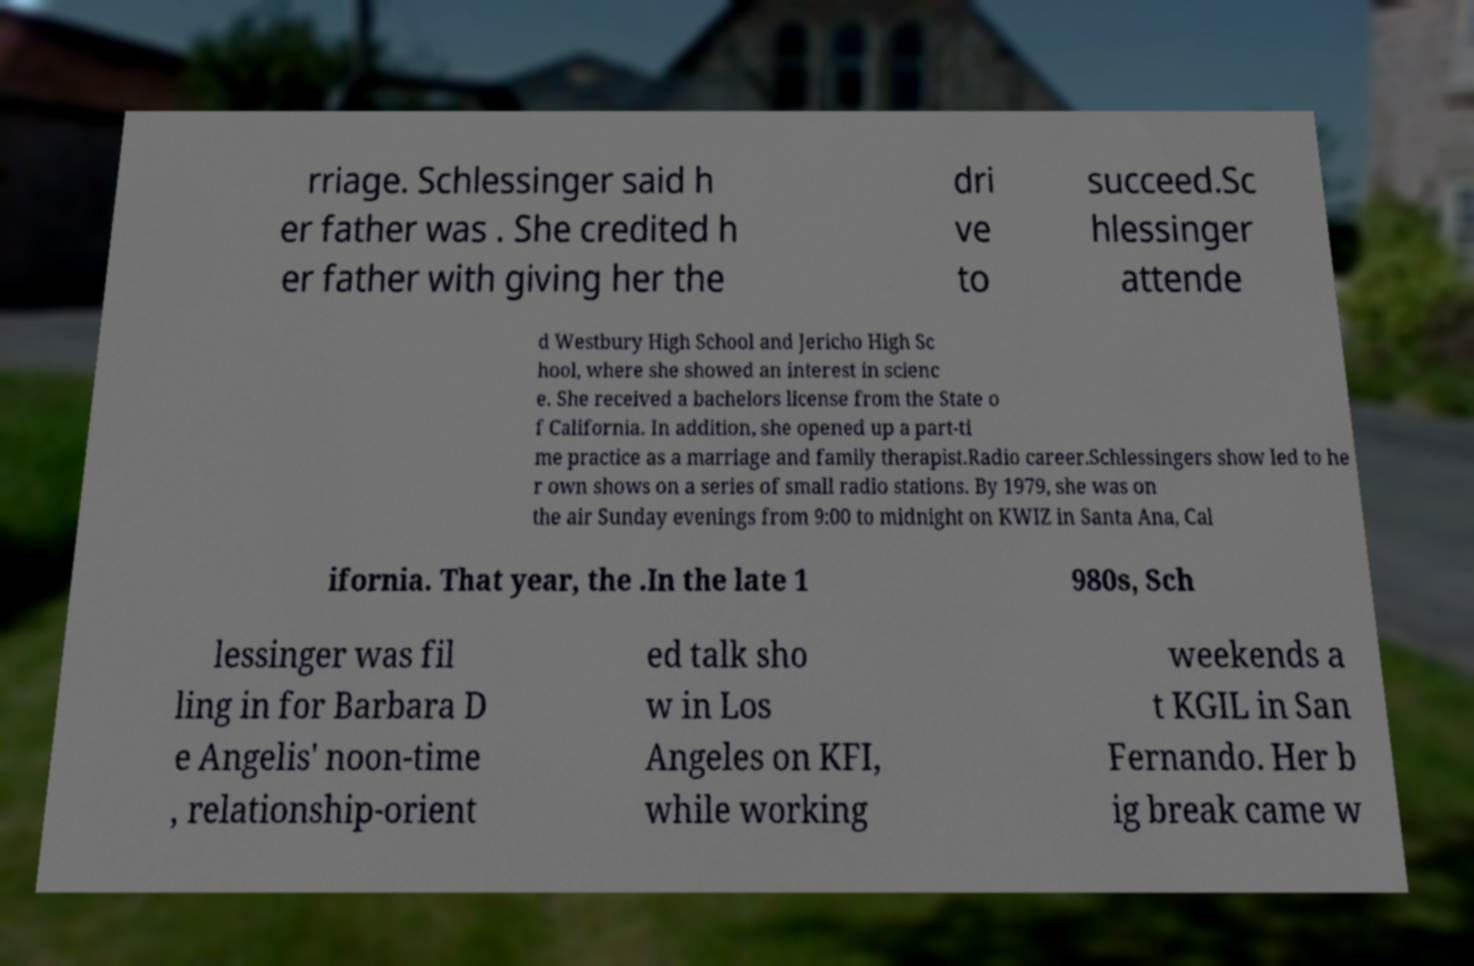There's text embedded in this image that I need extracted. Can you transcribe it verbatim? rriage. Schlessinger said h er father was . She credited h er father with giving her the dri ve to succeed.Sc hlessinger attende d Westbury High School and Jericho High Sc hool, where she showed an interest in scienc e. She received a bachelors license from the State o f California. In addition, she opened up a part-ti me practice as a marriage and family therapist.Radio career.Schlessingers show led to he r own shows on a series of small radio stations. By 1979, she was on the air Sunday evenings from 9:00 to midnight on KWIZ in Santa Ana, Cal ifornia. That year, the .In the late 1 980s, Sch lessinger was fil ling in for Barbara D e Angelis' noon-time , relationship-orient ed talk sho w in Los Angeles on KFI, while working weekends a t KGIL in San Fernando. Her b ig break came w 